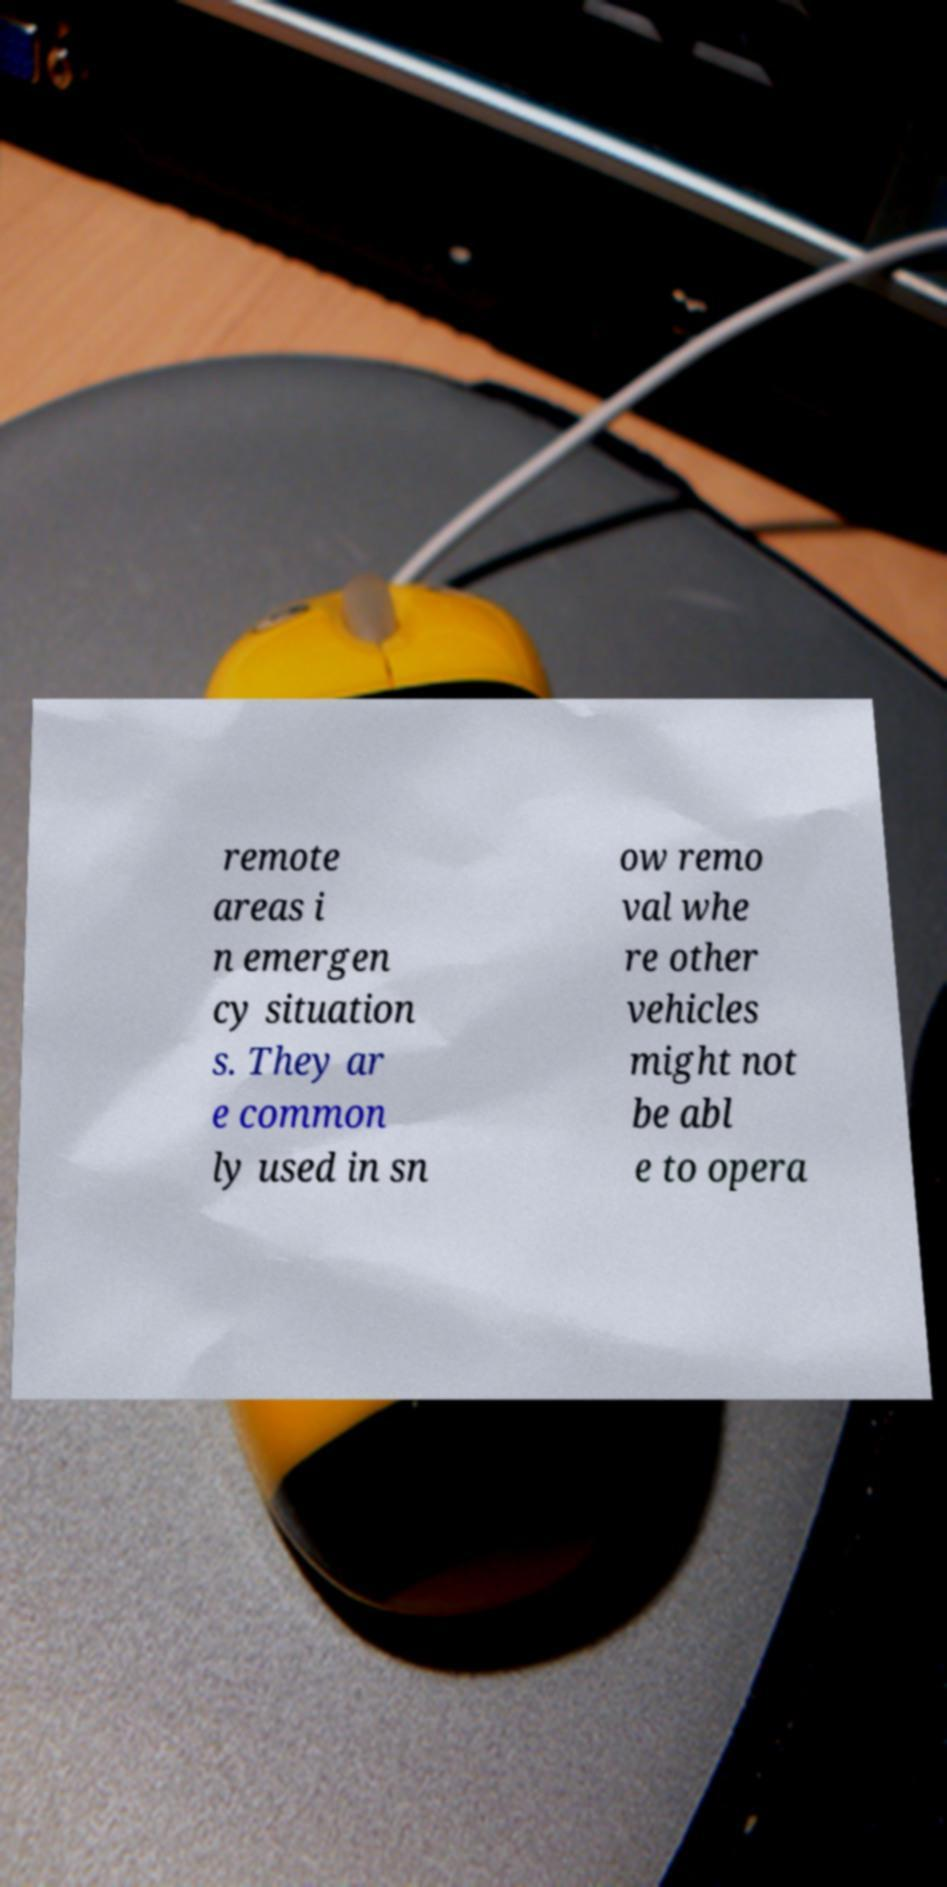There's text embedded in this image that I need extracted. Can you transcribe it verbatim? remote areas i n emergen cy situation s. They ar e common ly used in sn ow remo val whe re other vehicles might not be abl e to opera 